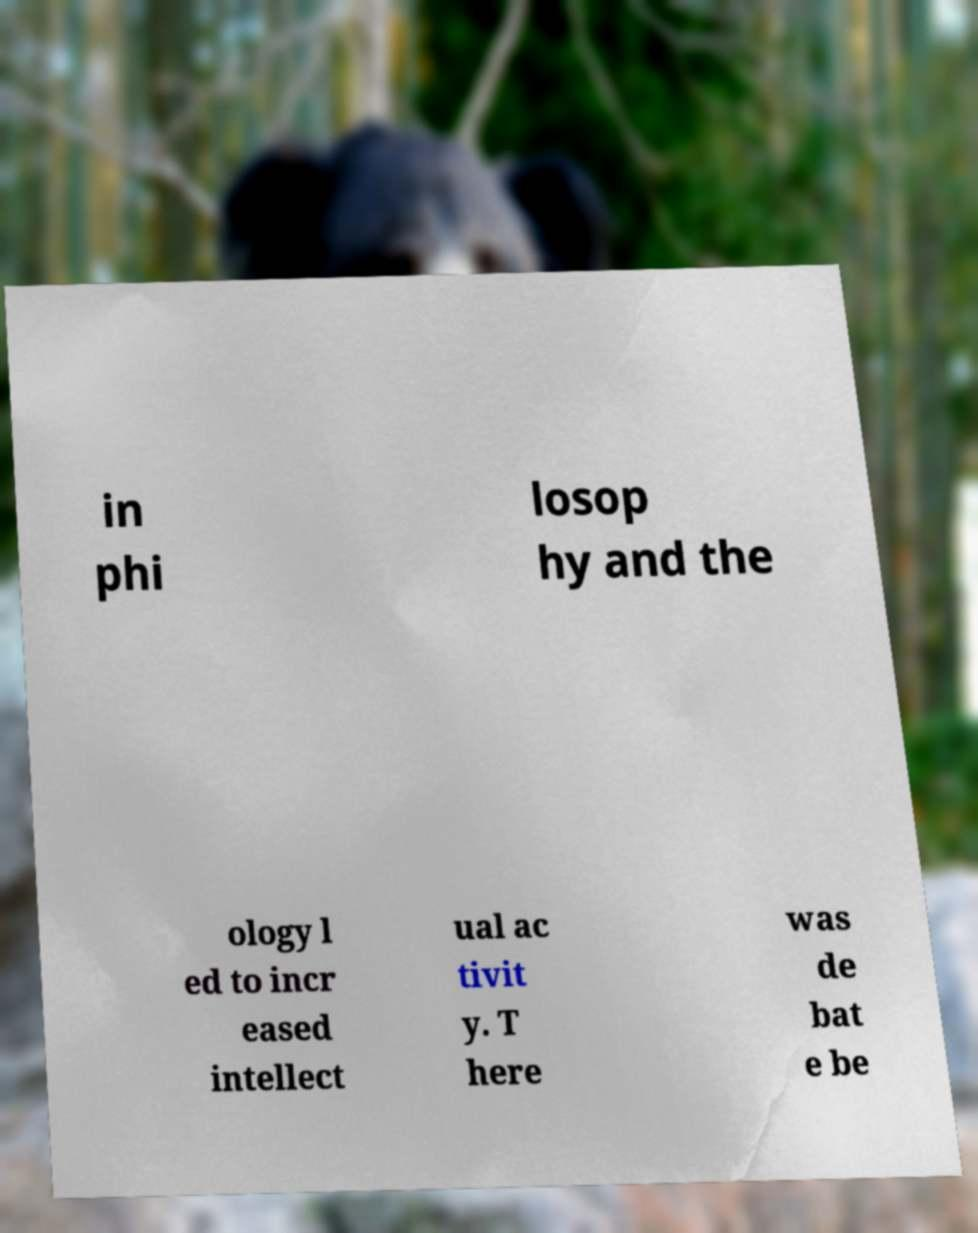Can you read and provide the text displayed in the image?This photo seems to have some interesting text. Can you extract and type it out for me? in phi losop hy and the ology l ed to incr eased intellect ual ac tivit y. T here was de bat e be 